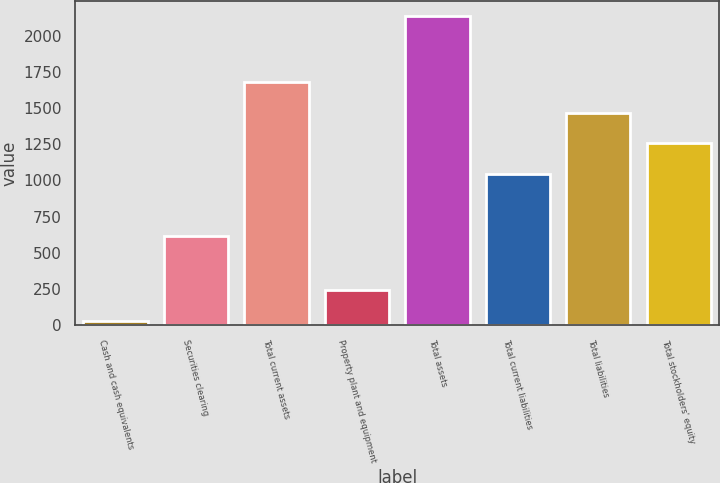Convert chart to OTSL. <chart><loc_0><loc_0><loc_500><loc_500><bar_chart><fcel>Cash and cash equivalents<fcel>Securities clearing<fcel>Total current assets<fcel>Property plant and equipment<fcel>Total assets<fcel>Total current liabilities<fcel>Total liabilities<fcel>Total stockholders' equity<nl><fcel>33.1<fcel>613.6<fcel>1677.44<fcel>243.26<fcel>2134.7<fcel>1046.96<fcel>1467.28<fcel>1257.12<nl></chart> 